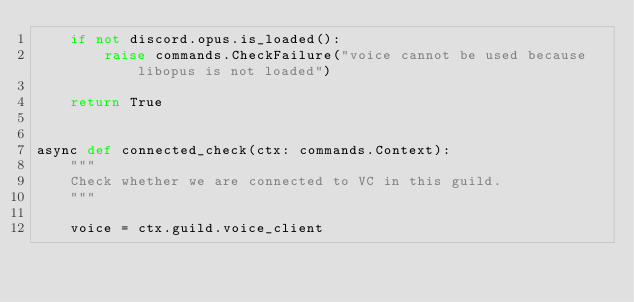<code> <loc_0><loc_0><loc_500><loc_500><_Python_>    if not discord.opus.is_loaded():
        raise commands.CheckFailure("voice cannot be used because libopus is not loaded")

    return True


async def connected_check(ctx: commands.Context):
    """
    Check whether we are connected to VC in this guild.
    """

    voice = ctx.guild.voice_client
</code> 